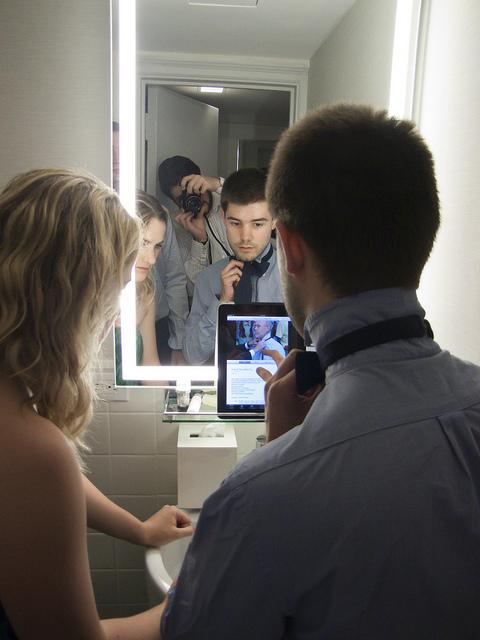What room are they in?
Give a very brief answer. Bathroom. What is this guy using his tablet to learn?
Concise answer only. Tie tie. Is there an attic above this room?
Answer briefly. No. 